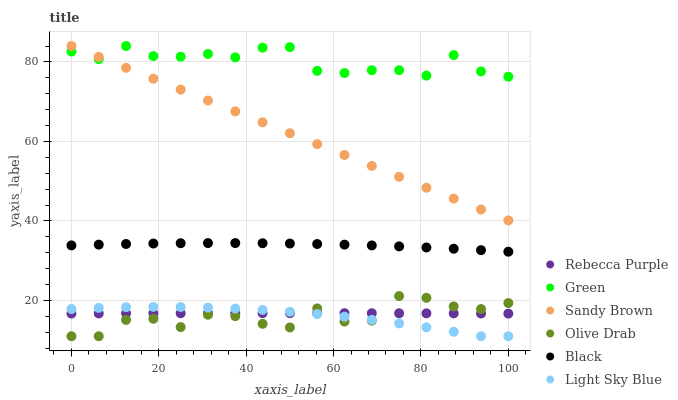Does Olive Drab have the minimum area under the curve?
Answer yes or no. Yes. Does Green have the maximum area under the curve?
Answer yes or no. Yes. Does Rebecca Purple have the minimum area under the curve?
Answer yes or no. No. Does Rebecca Purple have the maximum area under the curve?
Answer yes or no. No. Is Sandy Brown the smoothest?
Answer yes or no. Yes. Is Olive Drab the roughest?
Answer yes or no. Yes. Is Green the smoothest?
Answer yes or no. No. Is Green the roughest?
Answer yes or no. No. Does Light Sky Blue have the lowest value?
Answer yes or no. Yes. Does Rebecca Purple have the lowest value?
Answer yes or no. No. Does Sandy Brown have the highest value?
Answer yes or no. Yes. Does Rebecca Purple have the highest value?
Answer yes or no. No. Is Black less than Green?
Answer yes or no. Yes. Is Green greater than Olive Drab?
Answer yes or no. Yes. Does Rebecca Purple intersect Light Sky Blue?
Answer yes or no. Yes. Is Rebecca Purple less than Light Sky Blue?
Answer yes or no. No. Is Rebecca Purple greater than Light Sky Blue?
Answer yes or no. No. Does Black intersect Green?
Answer yes or no. No. 